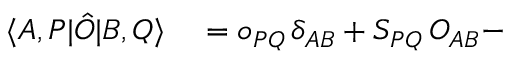<formula> <loc_0><loc_0><loc_500><loc_500>\begin{array} { r l } { \langle A , P | \hat { O } | B , Q \rangle } & = o _ { P Q } \, \delta _ { A B } + S _ { P Q } \, O _ { A B } - } \end{array}</formula> 